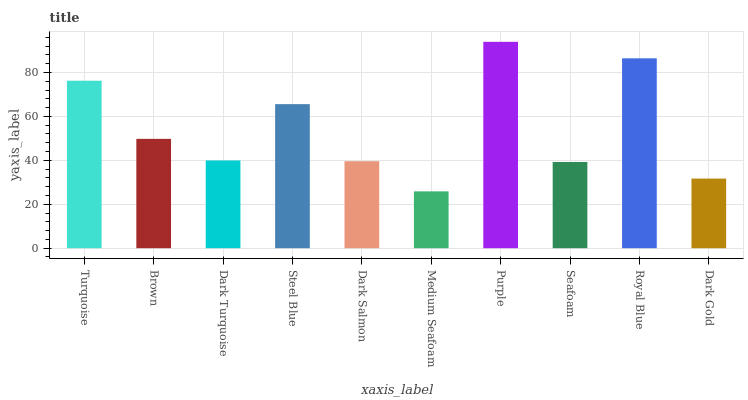Is Brown the minimum?
Answer yes or no. No. Is Brown the maximum?
Answer yes or no. No. Is Turquoise greater than Brown?
Answer yes or no. Yes. Is Brown less than Turquoise?
Answer yes or no. Yes. Is Brown greater than Turquoise?
Answer yes or no. No. Is Turquoise less than Brown?
Answer yes or no. No. Is Brown the high median?
Answer yes or no. Yes. Is Dark Turquoise the low median?
Answer yes or no. Yes. Is Royal Blue the high median?
Answer yes or no. No. Is Purple the low median?
Answer yes or no. No. 